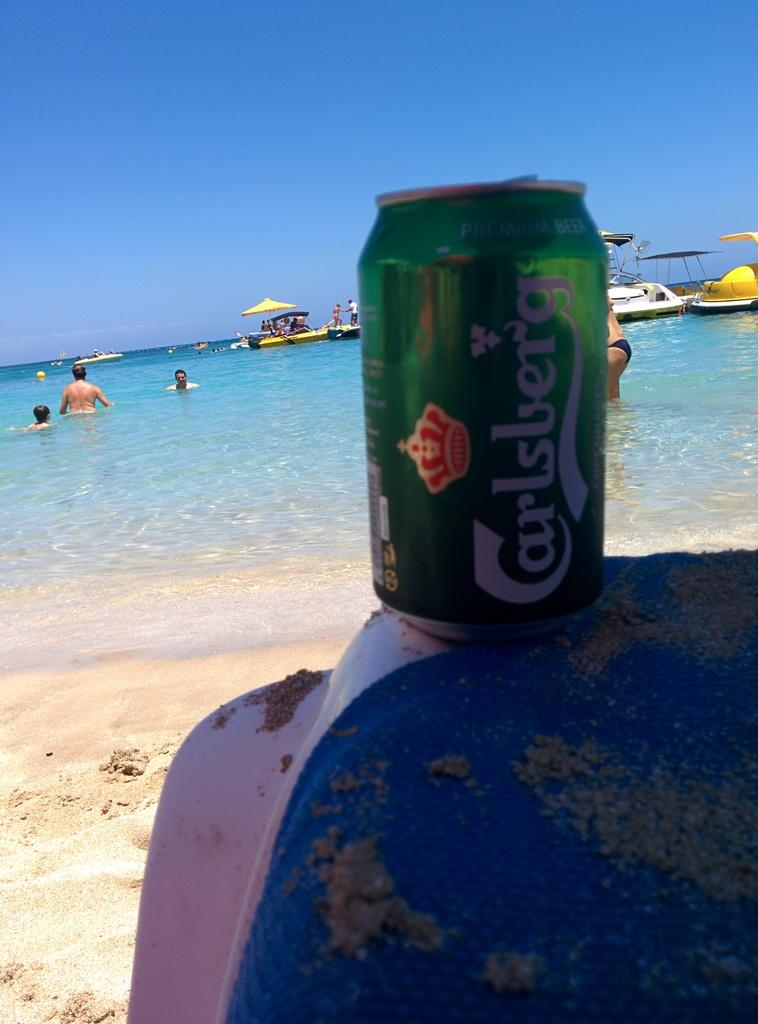<image>
Provide a brief description of the given image. A green can of Carlsberg beer sits on the edge of a sandy beach chair. 